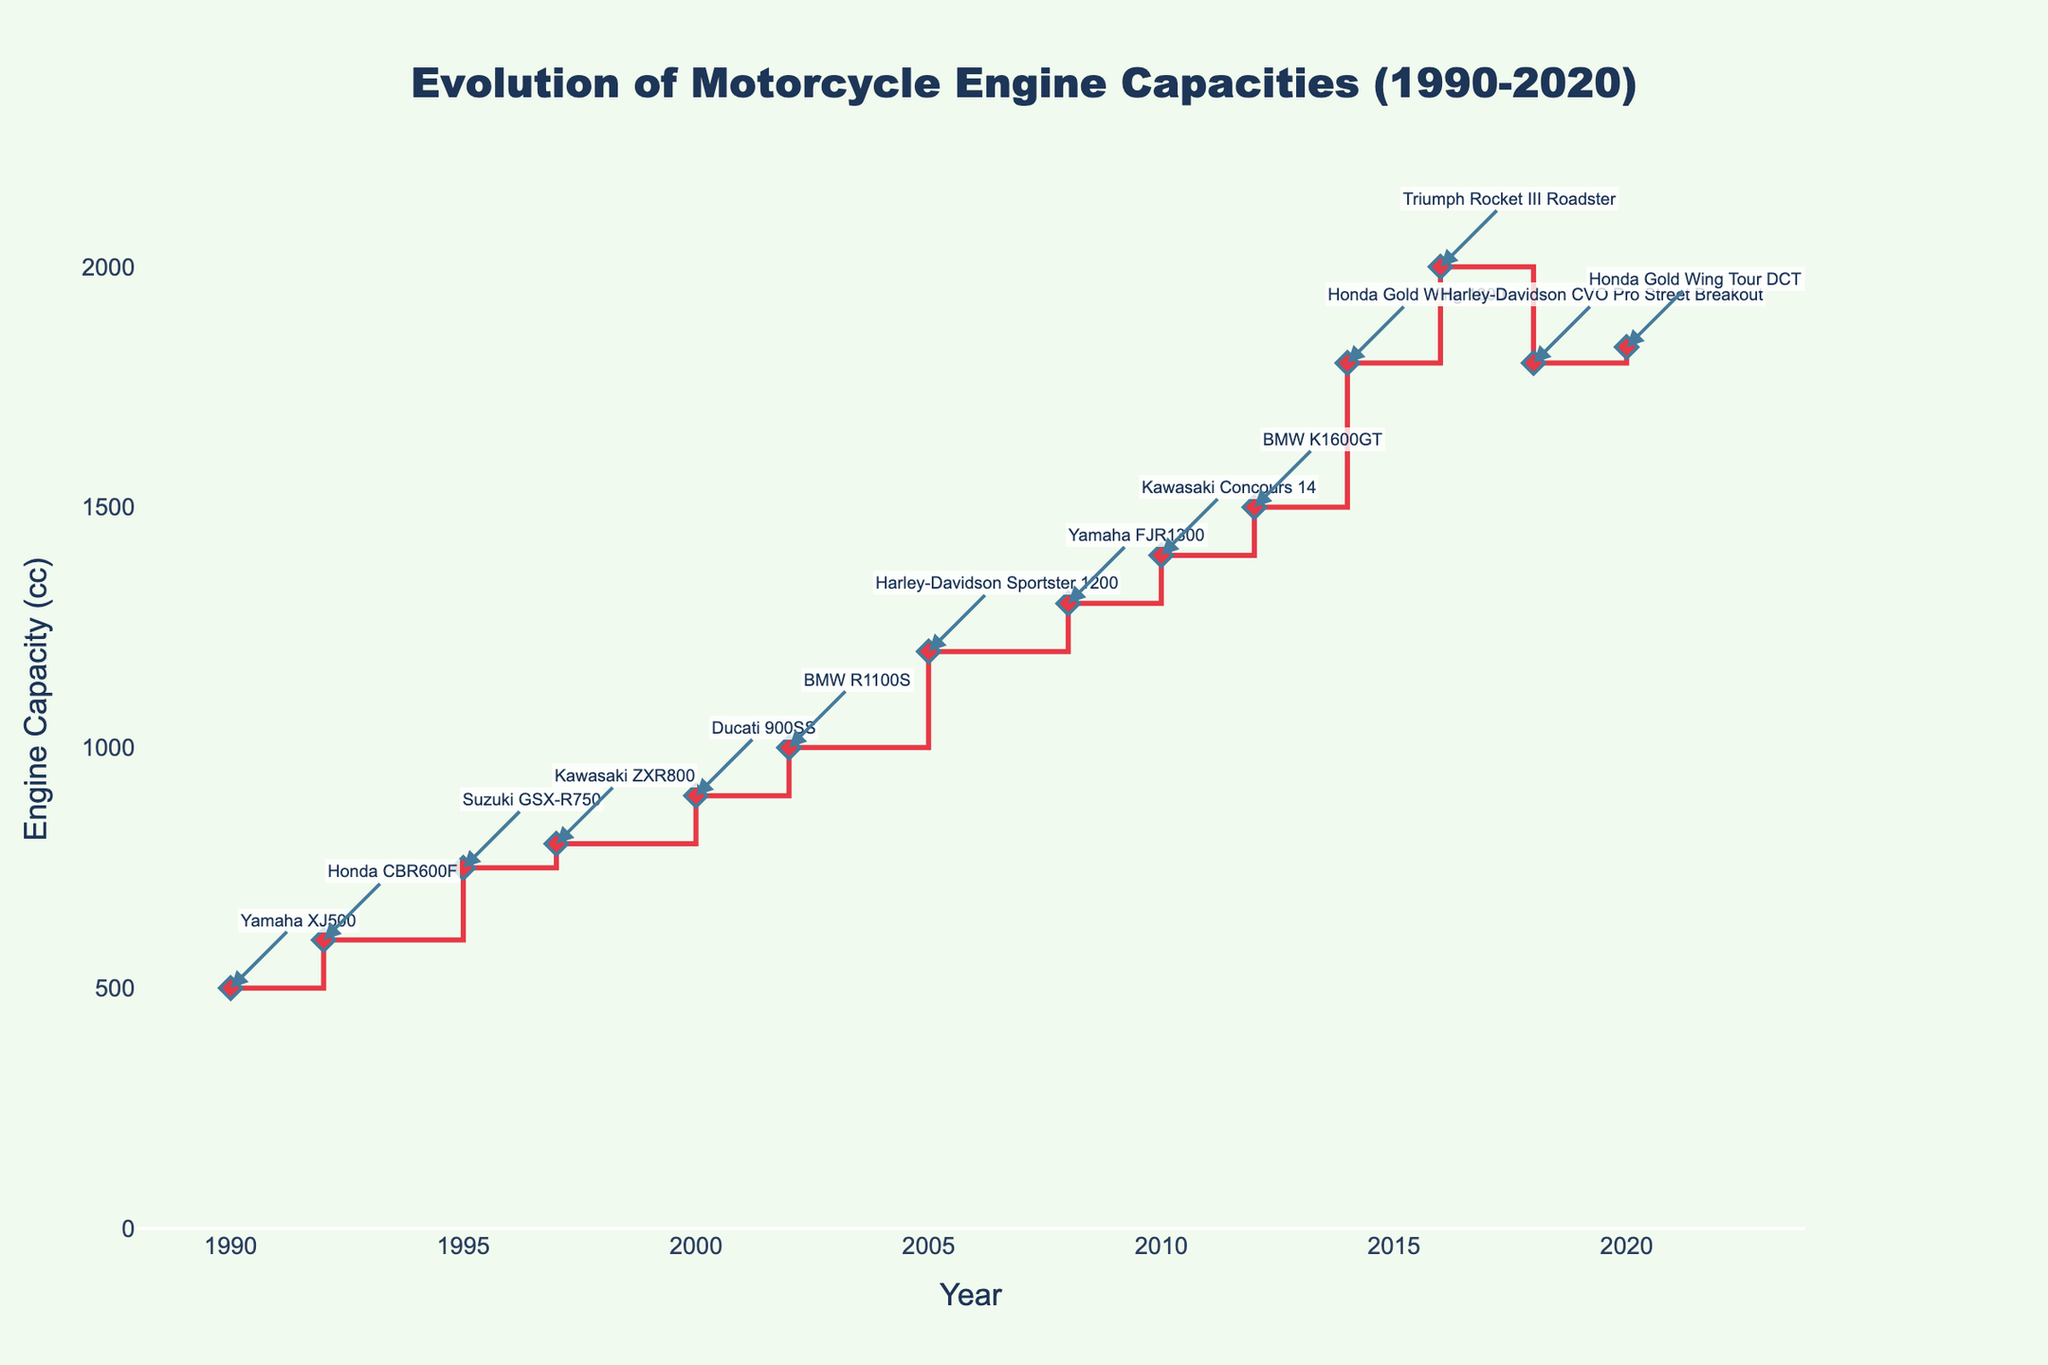what is the title of the plot? The title is visible at the top of the plot. It reads "Evolution of Motorcycle Engine Capacities (1990-2020)"
Answer: Evolution of Motorcycle Engine Capacities (1990-2020) how many data points are in the plot? Each marker on the plot represents a data point. There are markers positioned at each annotated year from 1990 to 2020, totaling 14 data points.
Answer: 14 what is the engine capacity in the year 2016? Locate the marker at the year 2016. The label indicates it is associated with an engine capacity of 2000 cc, belonging to the Triumph Rocket III Roadster.
Answer: 2000 cc which year marks the highest engine capacity and what is it? Identify the highest point on the y-axis. The annotation reveals it's in the year 2020 with the Honda Gold Wing Tour DCT having an engine capacity of 1833 cc.
Answer: 2020, 1833 cc did the engine capacity always increase over time? Observe the trend in the plot. Engine capacity did increase most of the time, but slight decreases or stagnations occurred, such as between 2016 and 2018 and then a slight increase again in 2020.
Answer: No what is the average engine capacity over the years? Sum all the engine capacities noted on the plot and divide by the number of years: (500+600+750+800+900+1000+1200+1300+1400+1500+1800+2000+1800+1833)/14. This results in an average of approximately 1230.21 cc.
Answer: 1230.21 cc which model has the largest engine capacity and what year is it from? The highest marker's annotation indicates that the model with the largest engine capacity is the Honda Gold Wing Tour DCT in 2020.
Answer: Honda Gold Wing Tour DCT, 2020 which bike model had an engine capacity of 750 cc? Locate the marker with the engine capacity 750 cc. The annotation points it to the year 1995 for the Suzuki GSX-R750.
Answer: Suzuki GSX-R750, 1995 what is the difference in engine capacity between the years 2000 and 2014? Find the capacities for 2000 (900 cc) and 2014 (1800 cc). The difference is 1800 - 900 = 900 cc.
Answer: 900 cc by how much did the engine capacity increase between 2005 and 2012? Determine the engine capacities for the years 2005 (1200 cc) and 2012 (1500 cc). The increase is 1500 - 1200 = 300 cc.
Answer: 300 cc 